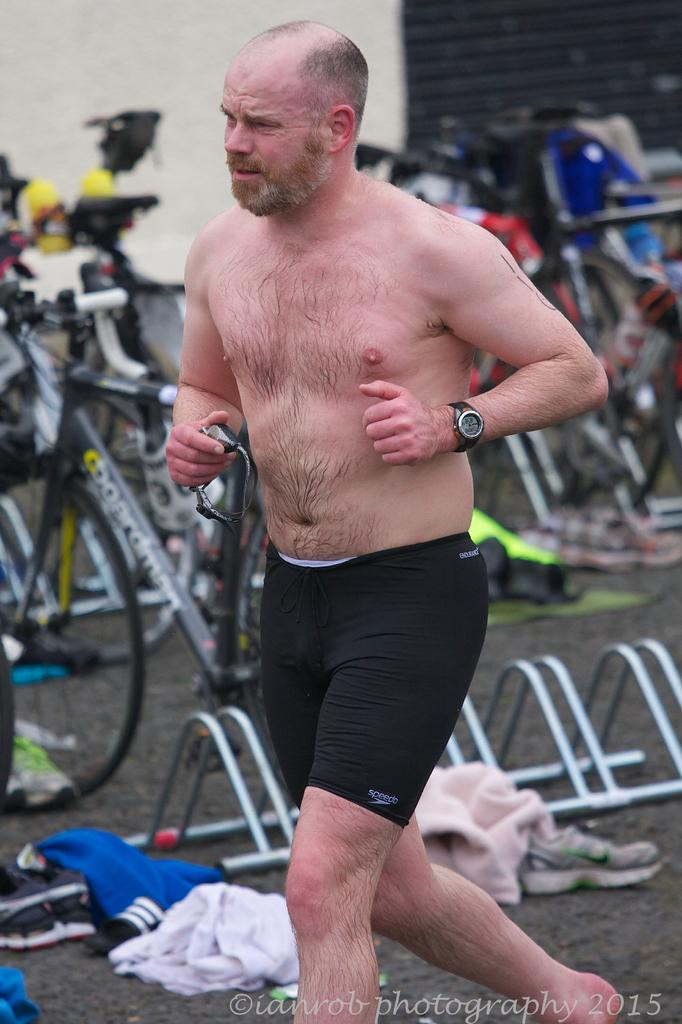What is the man in the image doing? The man is running in the image. What can be seen in the background of the image? There are bicycles in the background of the image. What is on the ground in the image? There are clothes on the ground in the image. What type of footwear is visible in the image? There are shoes in the image. What type of flock is flying over the man in the image? There is no flock of birds or animals visible in the image. 